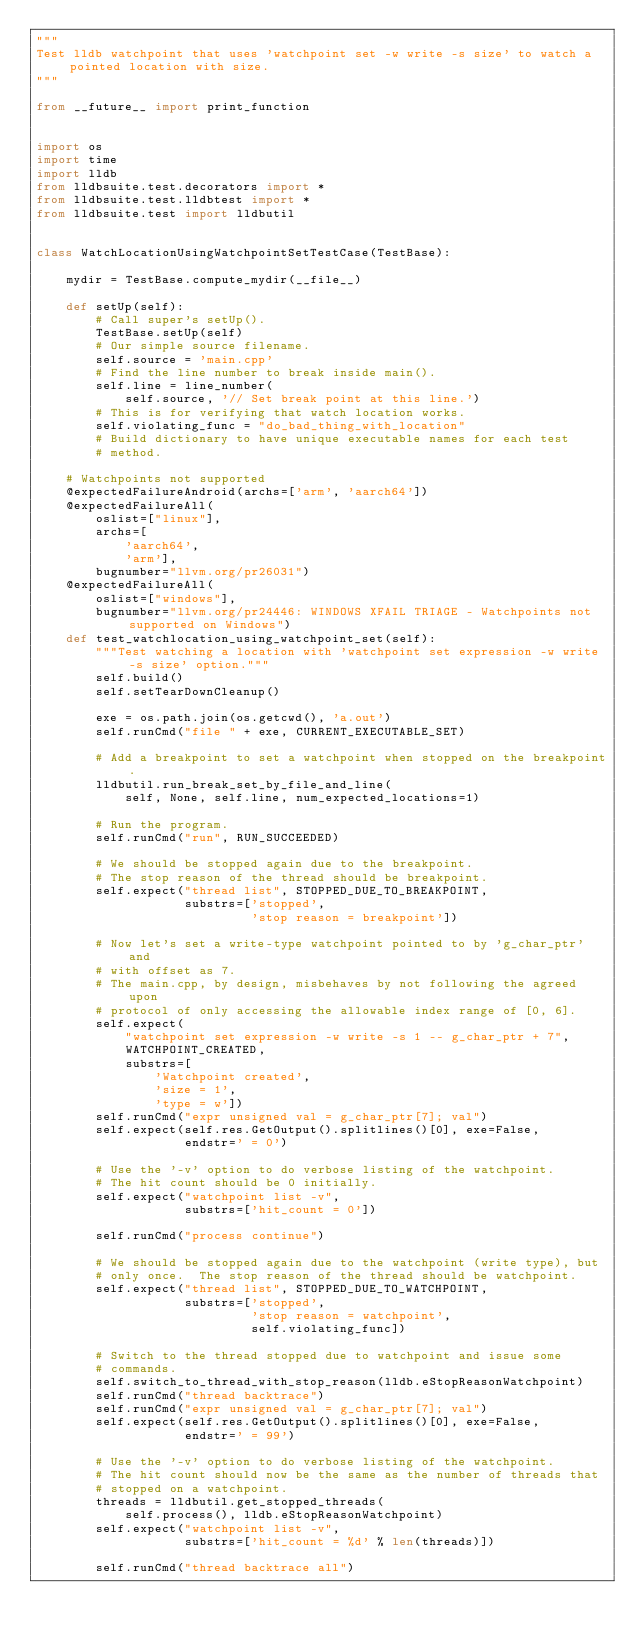<code> <loc_0><loc_0><loc_500><loc_500><_Python_>"""
Test lldb watchpoint that uses 'watchpoint set -w write -s size' to watch a pointed location with size.
"""

from __future__ import print_function


import os
import time
import lldb
from lldbsuite.test.decorators import *
from lldbsuite.test.lldbtest import *
from lldbsuite.test import lldbutil


class WatchLocationUsingWatchpointSetTestCase(TestBase):

    mydir = TestBase.compute_mydir(__file__)

    def setUp(self):
        # Call super's setUp().
        TestBase.setUp(self)
        # Our simple source filename.
        self.source = 'main.cpp'
        # Find the line number to break inside main().
        self.line = line_number(
            self.source, '// Set break point at this line.')
        # This is for verifying that watch location works.
        self.violating_func = "do_bad_thing_with_location"
        # Build dictionary to have unique executable names for each test
        # method.

    # Watchpoints not supported
    @expectedFailureAndroid(archs=['arm', 'aarch64'])
    @expectedFailureAll(
        oslist=["linux"],
        archs=[
            'aarch64',
            'arm'],
        bugnumber="llvm.org/pr26031")
    @expectedFailureAll(
        oslist=["windows"],
        bugnumber="llvm.org/pr24446: WINDOWS XFAIL TRIAGE - Watchpoints not supported on Windows")
    def test_watchlocation_using_watchpoint_set(self):
        """Test watching a location with 'watchpoint set expression -w write -s size' option."""
        self.build()
        self.setTearDownCleanup()

        exe = os.path.join(os.getcwd(), 'a.out')
        self.runCmd("file " + exe, CURRENT_EXECUTABLE_SET)

        # Add a breakpoint to set a watchpoint when stopped on the breakpoint.
        lldbutil.run_break_set_by_file_and_line(
            self, None, self.line, num_expected_locations=1)

        # Run the program.
        self.runCmd("run", RUN_SUCCEEDED)

        # We should be stopped again due to the breakpoint.
        # The stop reason of the thread should be breakpoint.
        self.expect("thread list", STOPPED_DUE_TO_BREAKPOINT,
                    substrs=['stopped',
                             'stop reason = breakpoint'])

        # Now let's set a write-type watchpoint pointed to by 'g_char_ptr' and
        # with offset as 7.
        # The main.cpp, by design, misbehaves by not following the agreed upon
        # protocol of only accessing the allowable index range of [0, 6].
        self.expect(
            "watchpoint set expression -w write -s 1 -- g_char_ptr + 7",
            WATCHPOINT_CREATED,
            substrs=[
                'Watchpoint created',
                'size = 1',
                'type = w'])
        self.runCmd("expr unsigned val = g_char_ptr[7]; val")
        self.expect(self.res.GetOutput().splitlines()[0], exe=False,
                    endstr=' = 0')

        # Use the '-v' option to do verbose listing of the watchpoint.
        # The hit count should be 0 initially.
        self.expect("watchpoint list -v",
                    substrs=['hit_count = 0'])

        self.runCmd("process continue")

        # We should be stopped again due to the watchpoint (write type), but
        # only once.  The stop reason of the thread should be watchpoint.
        self.expect("thread list", STOPPED_DUE_TO_WATCHPOINT,
                    substrs=['stopped',
                             'stop reason = watchpoint',
                             self.violating_func])

        # Switch to the thread stopped due to watchpoint and issue some
        # commands.
        self.switch_to_thread_with_stop_reason(lldb.eStopReasonWatchpoint)
        self.runCmd("thread backtrace")
        self.runCmd("expr unsigned val = g_char_ptr[7]; val")
        self.expect(self.res.GetOutput().splitlines()[0], exe=False,
                    endstr=' = 99')

        # Use the '-v' option to do verbose listing of the watchpoint.
        # The hit count should now be the same as the number of threads that
        # stopped on a watchpoint.
        threads = lldbutil.get_stopped_threads(
            self.process(), lldb.eStopReasonWatchpoint)
        self.expect("watchpoint list -v",
                    substrs=['hit_count = %d' % len(threads)])

        self.runCmd("thread backtrace all")
</code> 